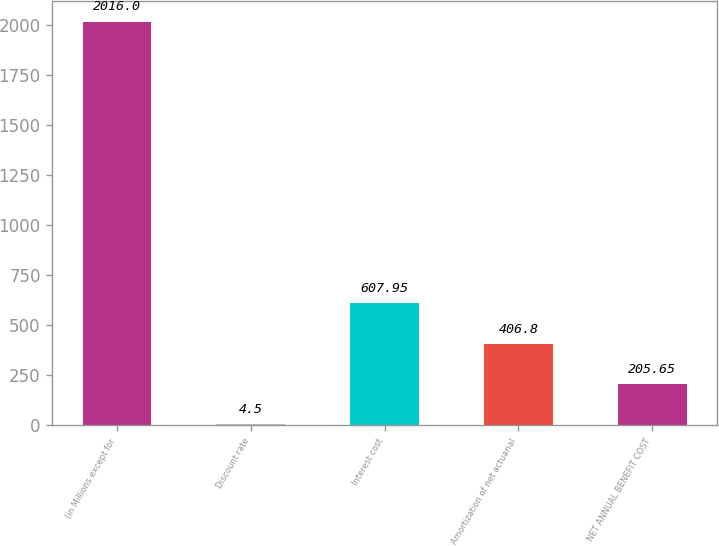<chart> <loc_0><loc_0><loc_500><loc_500><bar_chart><fcel>(in Millions except for<fcel>Discount rate<fcel>Interest cost<fcel>Amortization of net actuarial<fcel>NET ANNUAL BENEFIT COST<nl><fcel>2016<fcel>4.5<fcel>607.95<fcel>406.8<fcel>205.65<nl></chart> 